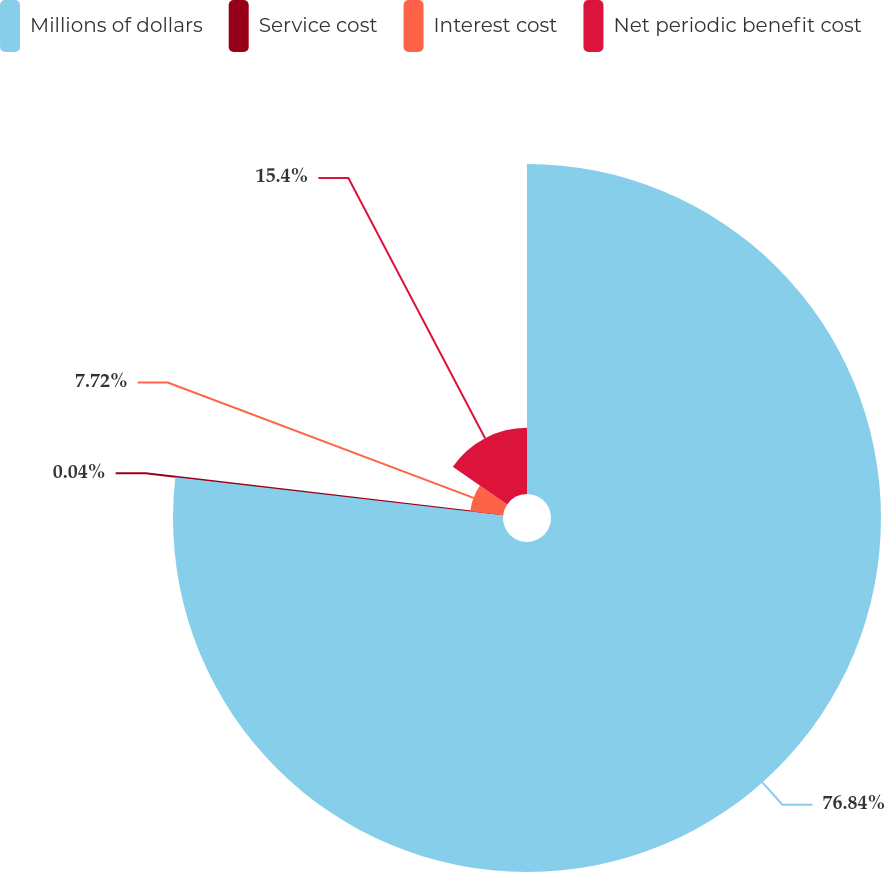Convert chart to OTSL. <chart><loc_0><loc_0><loc_500><loc_500><pie_chart><fcel>Millions of dollars<fcel>Service cost<fcel>Interest cost<fcel>Net periodic benefit cost<nl><fcel>76.84%<fcel>0.04%<fcel>7.72%<fcel>15.4%<nl></chart> 